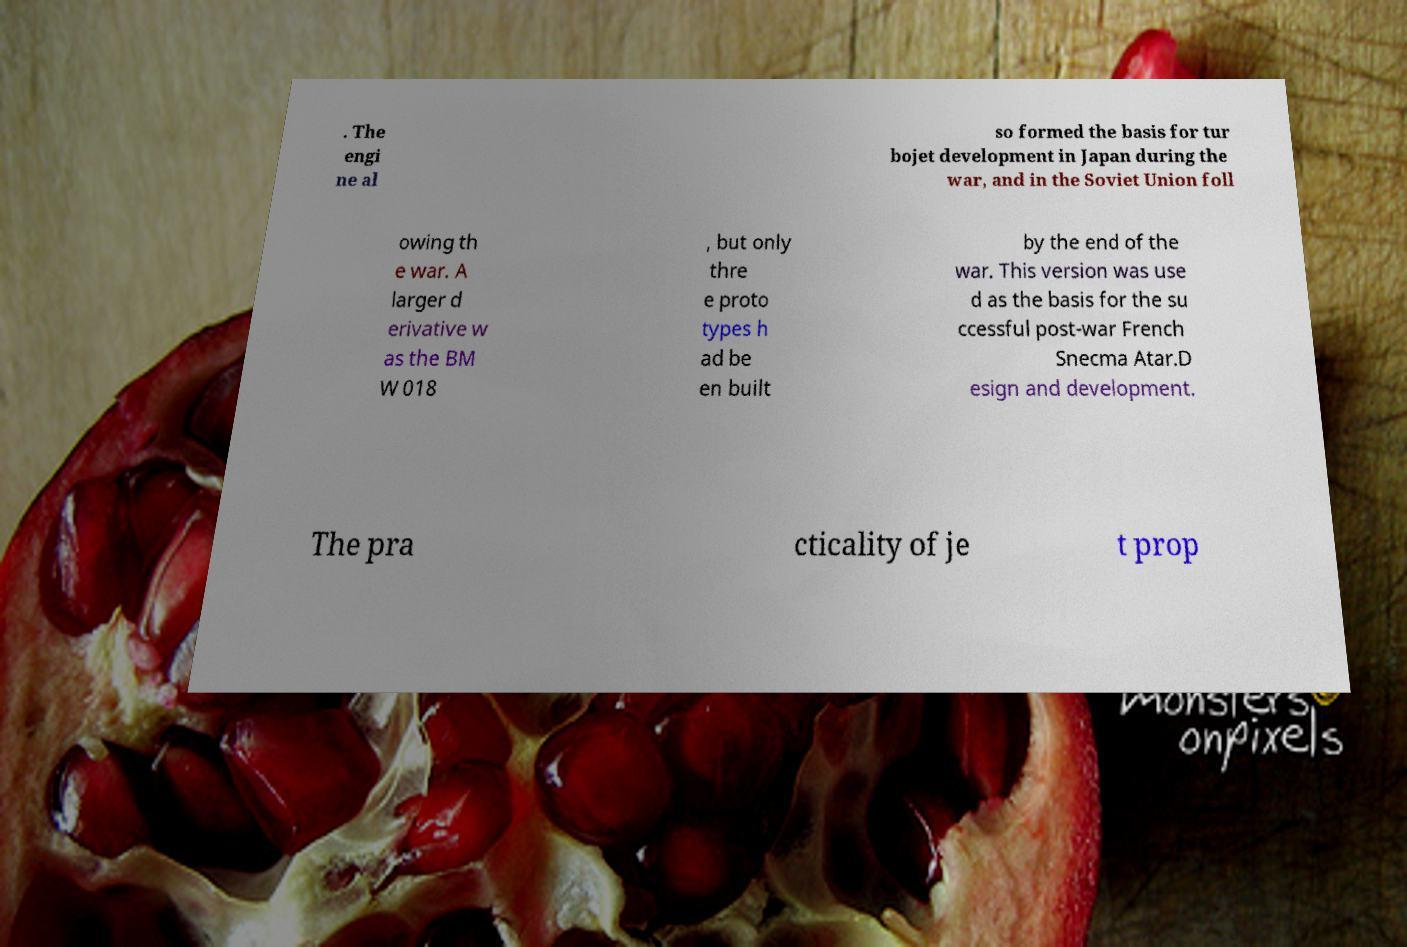Can you read and provide the text displayed in the image?This photo seems to have some interesting text. Can you extract and type it out for me? . The engi ne al so formed the basis for tur bojet development in Japan during the war, and in the Soviet Union foll owing th e war. A larger d erivative w as the BM W 018 , but only thre e proto types h ad be en built by the end of the war. This version was use d as the basis for the su ccessful post-war French Snecma Atar.D esign and development. The pra cticality of je t prop 